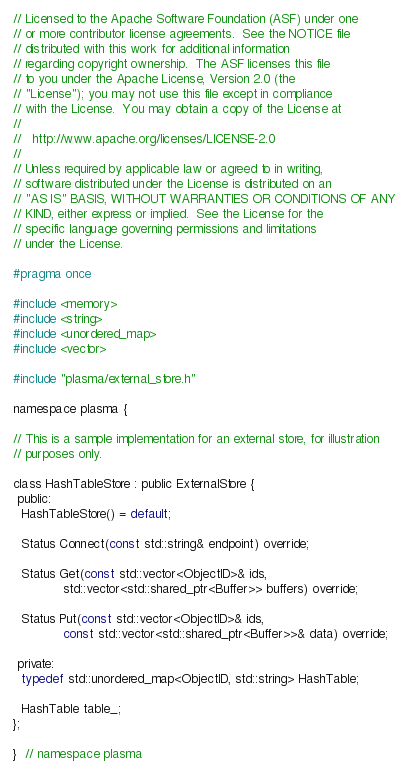<code> <loc_0><loc_0><loc_500><loc_500><_C_>// Licensed to the Apache Software Foundation (ASF) under one
// or more contributor license agreements.  See the NOTICE file
// distributed with this work for additional information
// regarding copyright ownership.  The ASF licenses this file
// to you under the Apache License, Version 2.0 (the
// "License"); you may not use this file except in compliance
// with the License.  You may obtain a copy of the License at
//
//   http://www.apache.org/licenses/LICENSE-2.0
//
// Unless required by applicable law or agreed to in writing,
// software distributed under the License is distributed on an
// "AS IS" BASIS, WITHOUT WARRANTIES OR CONDITIONS OF ANY
// KIND, either express or implied.  See the License for the
// specific language governing permissions and limitations
// under the License.

#pragma once

#include <memory>
#include <string>
#include <unordered_map>
#include <vector>

#include "plasma/external_store.h"

namespace plasma {

// This is a sample implementation for an external store, for illustration
// purposes only.

class HashTableStore : public ExternalStore {
 public:
  HashTableStore() = default;

  Status Connect(const std::string& endpoint) override;

  Status Get(const std::vector<ObjectID>& ids,
             std::vector<std::shared_ptr<Buffer>> buffers) override;

  Status Put(const std::vector<ObjectID>& ids,
             const std::vector<std::shared_ptr<Buffer>>& data) override;

 private:
  typedef std::unordered_map<ObjectID, std::string> HashTable;

  HashTable table_;
};

}  // namespace plasma
</code> 